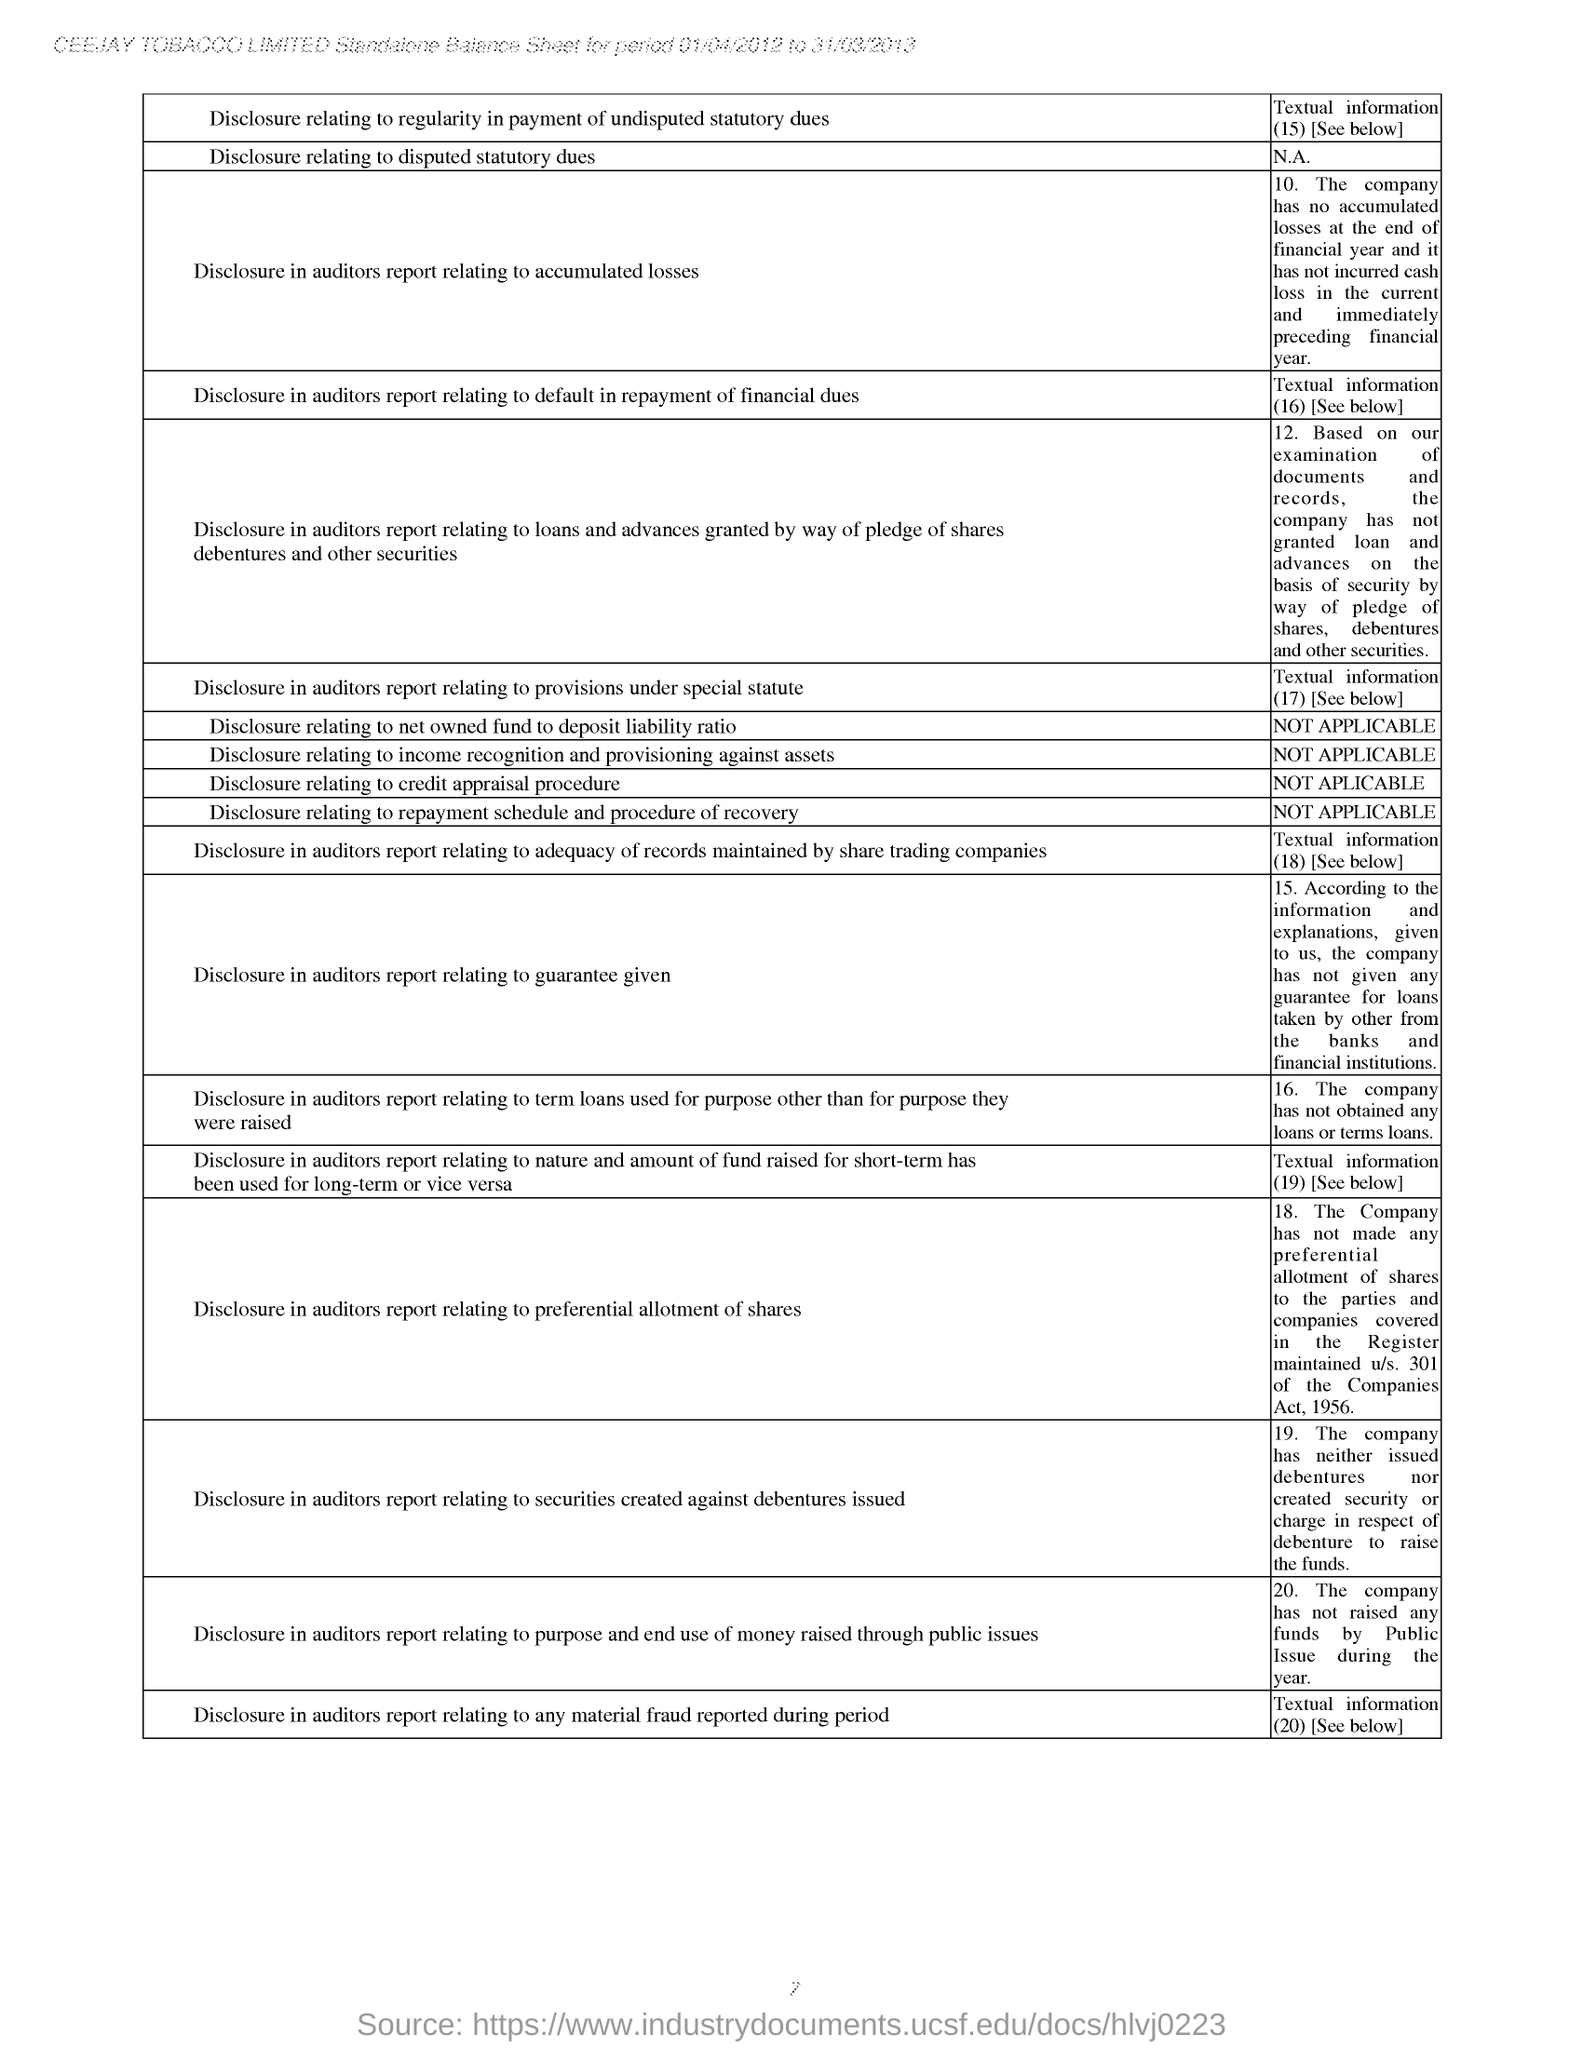Highlight a few significant elements in this photo. The period covered by the Standalone Balance Sheet according to the document header is from 01/04/2012 to 31/03/2013. The textual information numbered '16' is based on the second column of the table, which indicates that the company has not obtained any loans or terms loans. The company name located in the header of the document is CEEJAY TOBACCO LIMITED. 